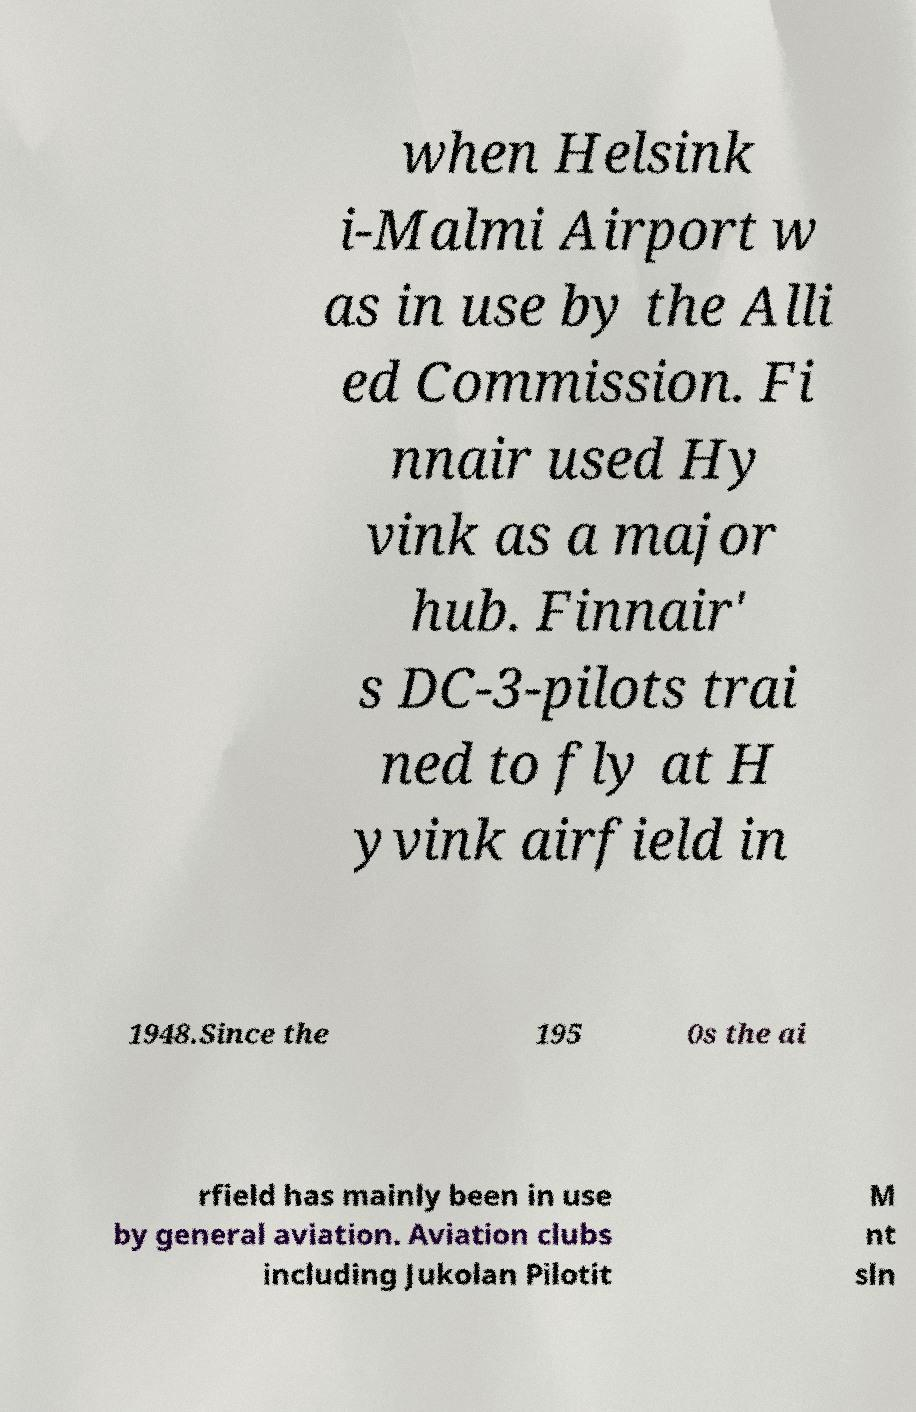For documentation purposes, I need the text within this image transcribed. Could you provide that? when Helsink i-Malmi Airport w as in use by the Alli ed Commission. Fi nnair used Hy vink as a major hub. Finnair' s DC-3-pilots trai ned to fly at H yvink airfield in 1948.Since the 195 0s the ai rfield has mainly been in use by general aviation. Aviation clubs including Jukolan Pilotit M nt sln 